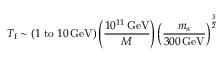<formula> <loc_0><loc_0><loc_500><loc_500>T _ { f } \sim \left ( 1 \, t o \, 1 0 \, G e V \right ) \left ( \frac { 1 0 ^ { 1 1 } \, G e V } { M } \right ) \left ( \frac { m _ { s } } { 3 0 0 \, G e V } \right ) ^ { \frac { 3 } { 2 } }</formula> 